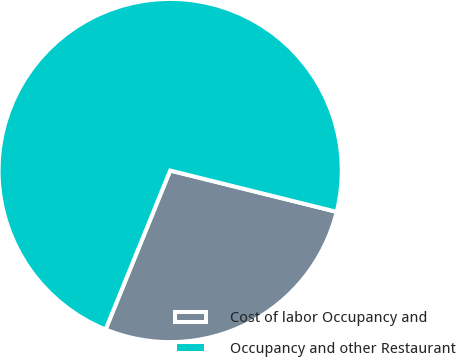Convert chart to OTSL. <chart><loc_0><loc_0><loc_500><loc_500><pie_chart><fcel>Cost of labor Occupancy and<fcel>Occupancy and other Restaurant<nl><fcel>27.27%<fcel>72.73%<nl></chart> 